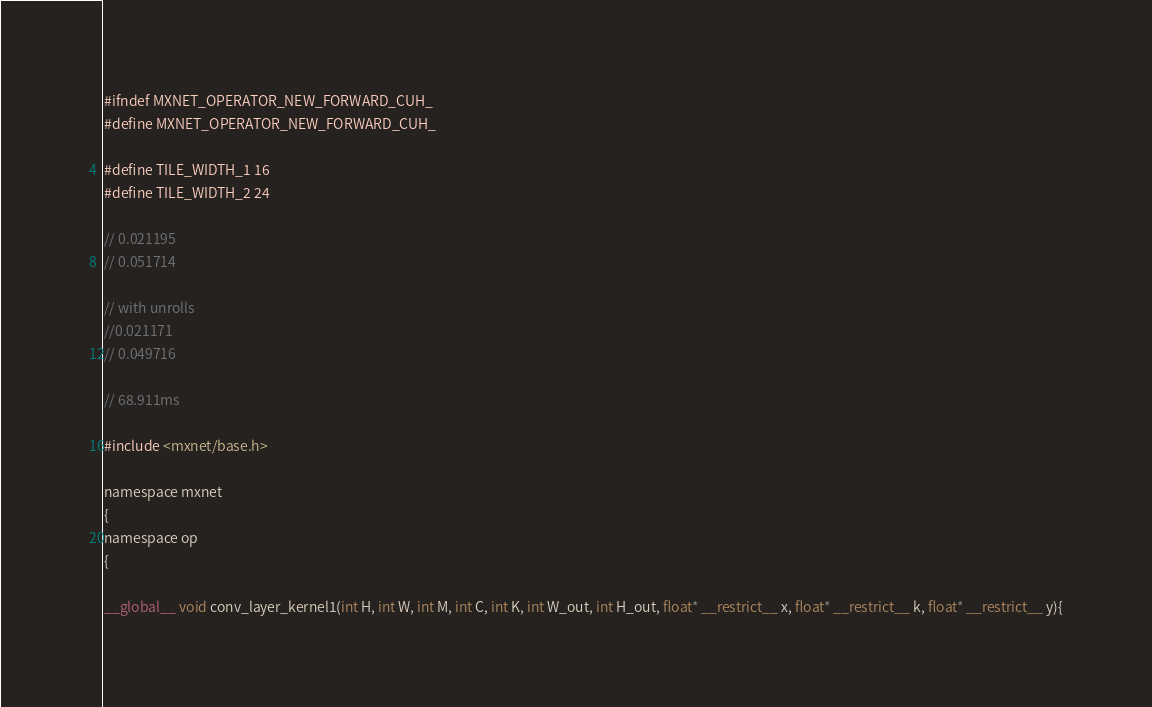Convert code to text. <code><loc_0><loc_0><loc_500><loc_500><_Cuda_>#ifndef MXNET_OPERATOR_NEW_FORWARD_CUH_
#define MXNET_OPERATOR_NEW_FORWARD_CUH_

#define TILE_WIDTH_1 16
#define TILE_WIDTH_2 24

// 0.021195
// 0.051714

// with unrolls
//0.021171
// 0.049716

// 68.911ms

#include <mxnet/base.h>

namespace mxnet
{
namespace op
{

__global__ void conv_layer_kernel1(int H, int W, int M, int C, int K, int W_out, int H_out, float* __restrict__ x, float* __restrict__ k, float* __restrict__ y){
</code> 